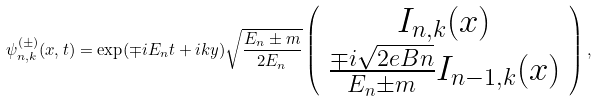Convert formula to latex. <formula><loc_0><loc_0><loc_500><loc_500>\psi _ { n , k } ^ { ( \pm ) } ( { x } , t ) = \exp ( \mp i E _ { n } t + i k y ) \sqrt { \frac { E _ { n } \pm m } { 2 E _ { n } } } \left ( \begin{array} { c } I _ { n , k } ( x ) \\ \frac { \mp i \sqrt { 2 e B n } } { E _ { n } \pm m } I _ { n - 1 , k } ( x ) \\ \end{array} \right ) ,</formula> 